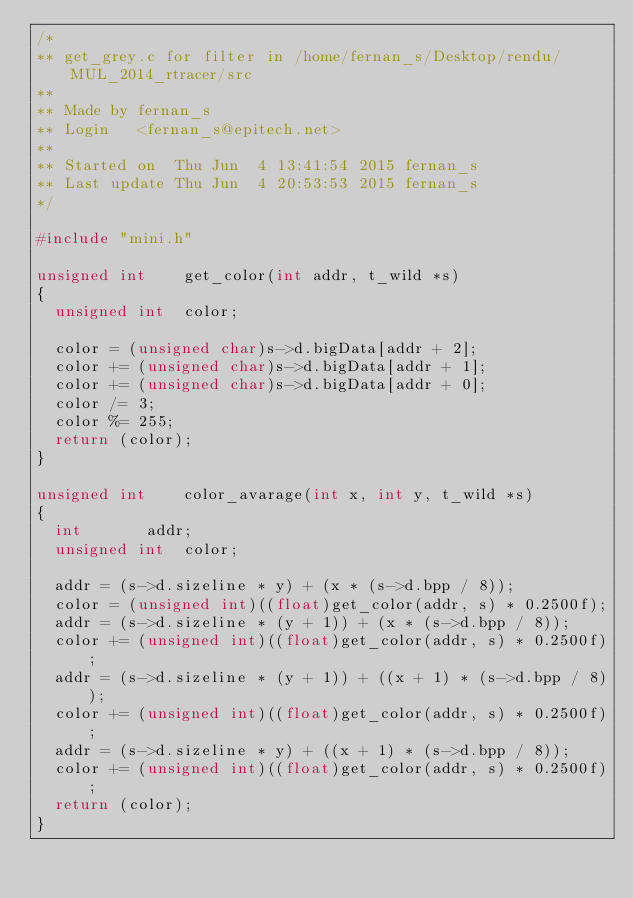Convert code to text. <code><loc_0><loc_0><loc_500><loc_500><_C_>/*
** get_grey.c for filter in /home/fernan_s/Desktop/rendu/MUL_2014_rtracer/src
** 
** Made by fernan_s
** Login   <fernan_s@epitech.net>
** 
** Started on  Thu Jun  4 13:41:54 2015 fernan_s
** Last update Thu Jun  4 20:53:53 2015 fernan_s
*/

#include "mini.h"

unsigned int	get_color(int addr, t_wild *s)
{
  unsigned int	color;

  color = (unsigned char)s->d.bigData[addr + 2];
  color += (unsigned char)s->d.bigData[addr + 1];
  color += (unsigned char)s->d.bigData[addr + 0];
  color /= 3;
  color %= 255;
  return (color);
}

unsigned int	color_avarage(int x, int y, t_wild *s)
{
  int		addr;
  unsigned int	color;

  addr = (s->d.sizeline * y) + (x * (s->d.bpp / 8));
  color = (unsigned int)((float)get_color(addr, s) * 0.2500f);
  addr = (s->d.sizeline * (y + 1)) + (x * (s->d.bpp / 8));
  color += (unsigned int)((float)get_color(addr, s) * 0.2500f);
  addr = (s->d.sizeline * (y + 1)) + ((x + 1) * (s->d.bpp / 8));
  color += (unsigned int)((float)get_color(addr, s) * 0.2500f);
  addr = (s->d.sizeline * y) + ((x + 1) * (s->d.bpp / 8));
  color += (unsigned int)((float)get_color(addr, s) * 0.2500f);
  return (color);
}
</code> 